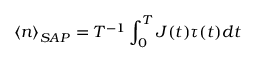<formula> <loc_0><loc_0><loc_500><loc_500>\left \langle n \right \rangle _ { S A P } = T ^ { - 1 } \int _ { 0 } ^ { T } J ( t ) \tau ( t ) d t</formula> 